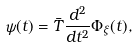<formula> <loc_0><loc_0><loc_500><loc_500>\psi ( t ) = \bar { T } \frac { d ^ { 2 } } { d t ^ { 2 } } \Phi _ { \xi } ( t ) ,</formula> 